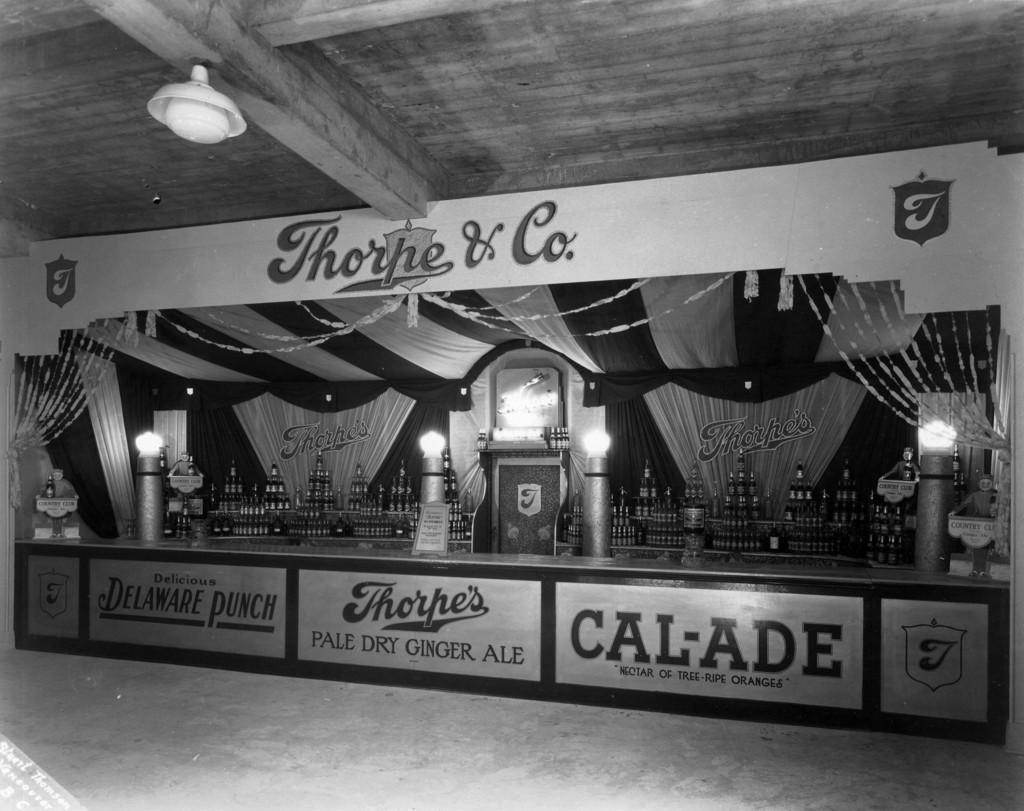What objects can be seen on the desk in the image? There are bottles on the desk in the image. What else is present in the image besides the desk? There are boards in the image. Can you describe the light arrangement in the image? There is a light arrangement on the roof in the image. What type of camera can be seen in the image? There is no camera present in the image. What invention is being demonstrated in the image? The image does not depict any specific invention being demonstrated. 